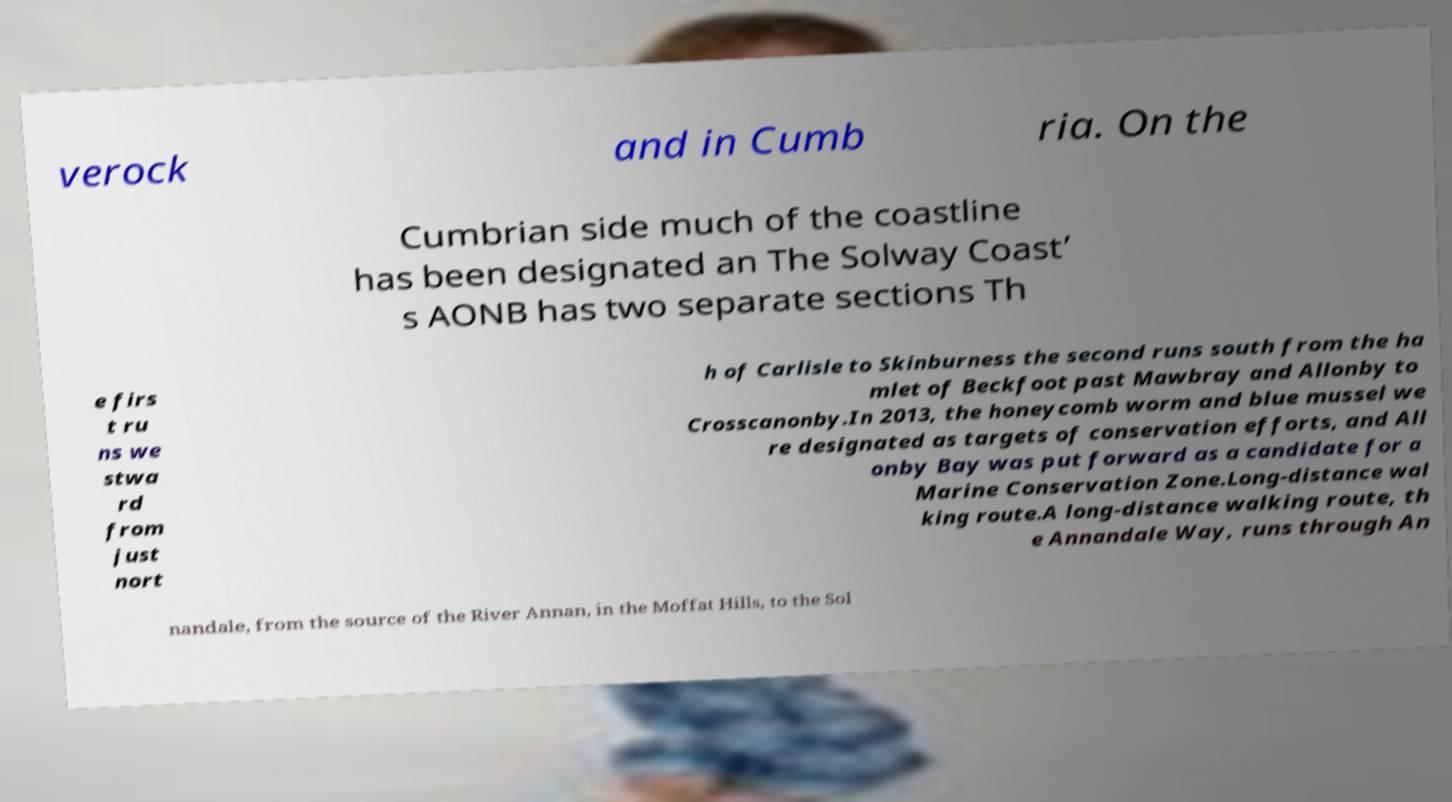Please read and relay the text visible in this image. What does it say? verock and in Cumb ria. On the Cumbrian side much of the coastline has been designated an The Solway Coast’ s AONB has two separate sections Th e firs t ru ns we stwa rd from just nort h of Carlisle to Skinburness the second runs south from the ha mlet of Beckfoot past Mawbray and Allonby to Crosscanonby.In 2013, the honeycomb worm and blue mussel we re designated as targets of conservation efforts, and All onby Bay was put forward as a candidate for a Marine Conservation Zone.Long-distance wal king route.A long-distance walking route, th e Annandale Way, runs through An nandale, from the source of the River Annan, in the Moffat Hills, to the Sol 